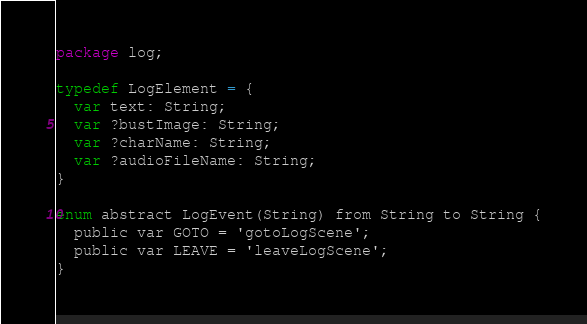<code> <loc_0><loc_0><loc_500><loc_500><_Haxe_>package log;

typedef LogElement = {
  var text: String;
  var ?bustImage: String;
  var ?charName: String;
  var ?audioFileName: String;
}

enum abstract LogEvent(String) from String to String {
  public var GOTO = 'gotoLogScene';
  public var LEAVE = 'leaveLogScene';
}
</code> 